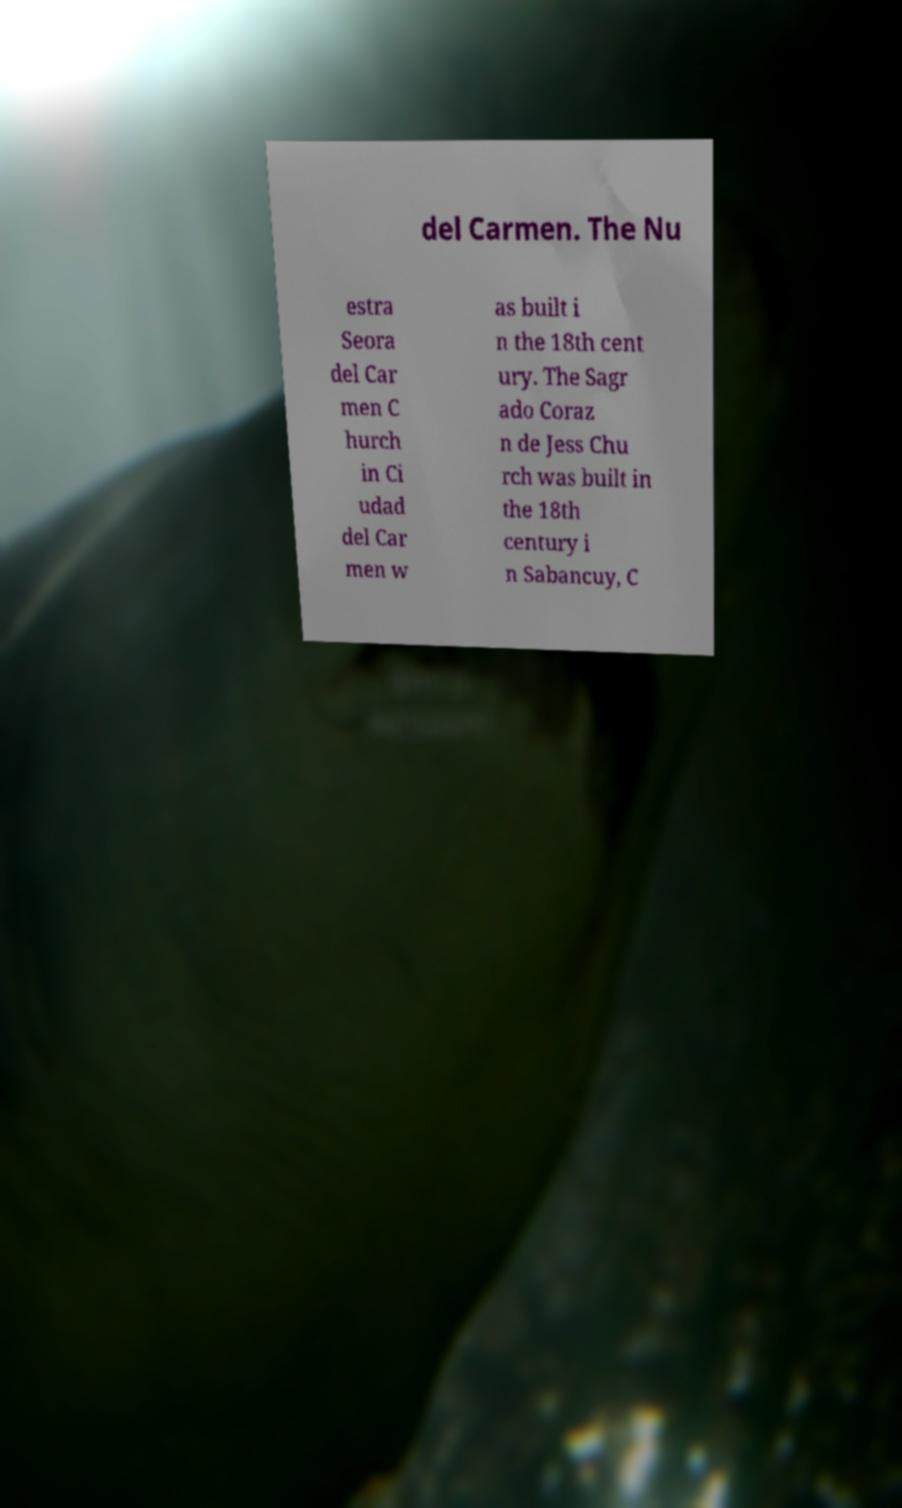There's text embedded in this image that I need extracted. Can you transcribe it verbatim? del Carmen. The Nu estra Seora del Car men C hurch in Ci udad del Car men w as built i n the 18th cent ury. The Sagr ado Coraz n de Jess Chu rch was built in the 18th century i n Sabancuy, C 